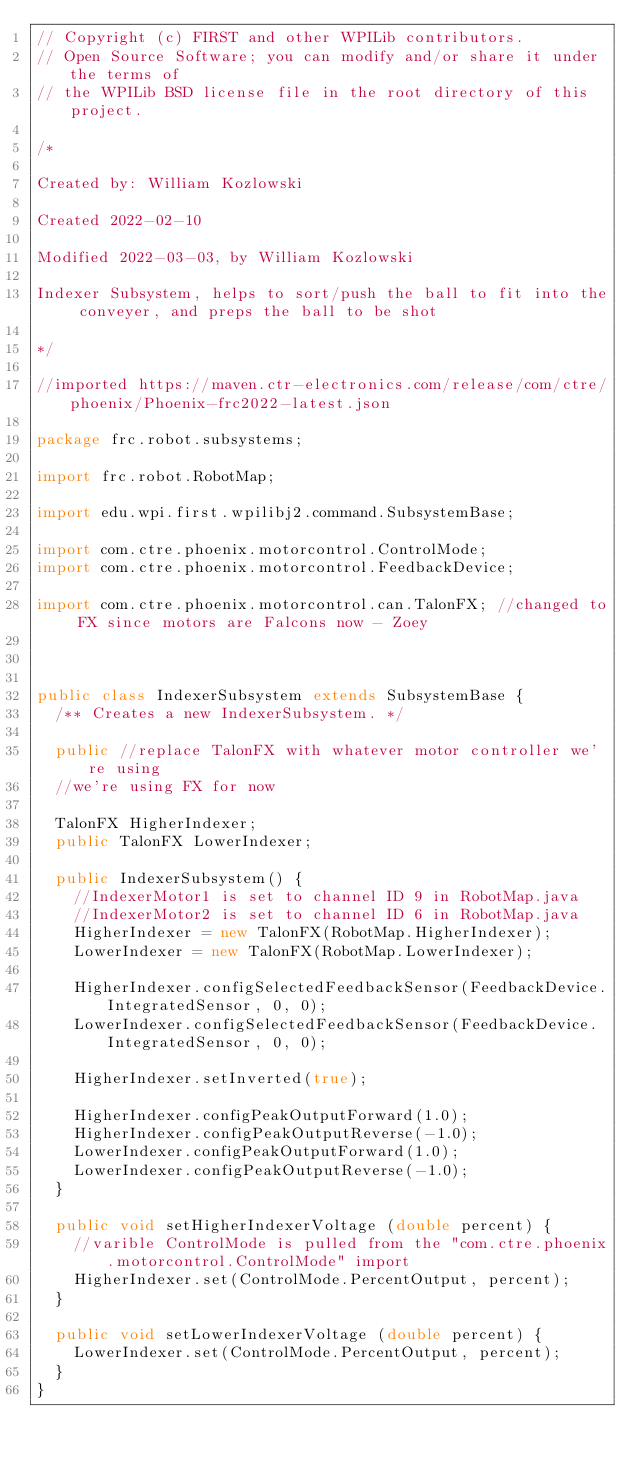Convert code to text. <code><loc_0><loc_0><loc_500><loc_500><_Java_>// Copyright (c) FIRST and other WPILib contributors.
// Open Source Software; you can modify and/or share it under the terms of
// the WPILib BSD license file in the root directory of this project.

/*

Created by: William Kozlowski

Created 2022-02-10

Modified 2022-03-03, by William Kozlowski

Indexer Subsystem, helps to sort/push the ball to fit into the conveyer, and preps the ball to be shot

*/

//imported https://maven.ctr-electronics.com/release/com/ctre/phoenix/Phoenix-frc2022-latest.json

package frc.robot.subsystems;

import frc.robot.RobotMap;

import edu.wpi.first.wpilibj2.command.SubsystemBase;

import com.ctre.phoenix.motorcontrol.ControlMode;
import com.ctre.phoenix.motorcontrol.FeedbackDevice;

import com.ctre.phoenix.motorcontrol.can.TalonFX; //changed to FX since motors are Falcons now - Zoey



public class IndexerSubsystem extends SubsystemBase {
  /** Creates a new IndexerSubsystem. */

  public //replace TalonFX with whatever motor controller we're using
  //we're using FX for now

  TalonFX HigherIndexer;
  public TalonFX LowerIndexer;

  public IndexerSubsystem() {
    //IndexerMotor1 is set to channel ID 9 in RobotMap.java
    //IndexerMotor2 is set to channel ID 6 in RobotMap.java
    HigherIndexer = new TalonFX(RobotMap.HigherIndexer);
    LowerIndexer = new TalonFX(RobotMap.LowerIndexer);
  
    HigherIndexer.configSelectedFeedbackSensor(FeedbackDevice.IntegratedSensor, 0, 0);
    LowerIndexer.configSelectedFeedbackSensor(FeedbackDevice.IntegratedSensor, 0, 0);

    HigherIndexer.setInverted(true);

    HigherIndexer.configPeakOutputForward(1.0);
    HigherIndexer.configPeakOutputReverse(-1.0);
    LowerIndexer.configPeakOutputForward(1.0);
    LowerIndexer.configPeakOutputReverse(-1.0);
  }

  public void setHigherIndexerVoltage (double percent) {
    //varible ControlMode is pulled from the "com.ctre.phoenix.motorcontrol.ControlMode" import
    HigherIndexer.set(ControlMode.PercentOutput, percent);
  }
  
  public void setLowerIndexerVoltage (double percent) {
    LowerIndexer.set(ControlMode.PercentOutput, percent);
  }
}
</code> 